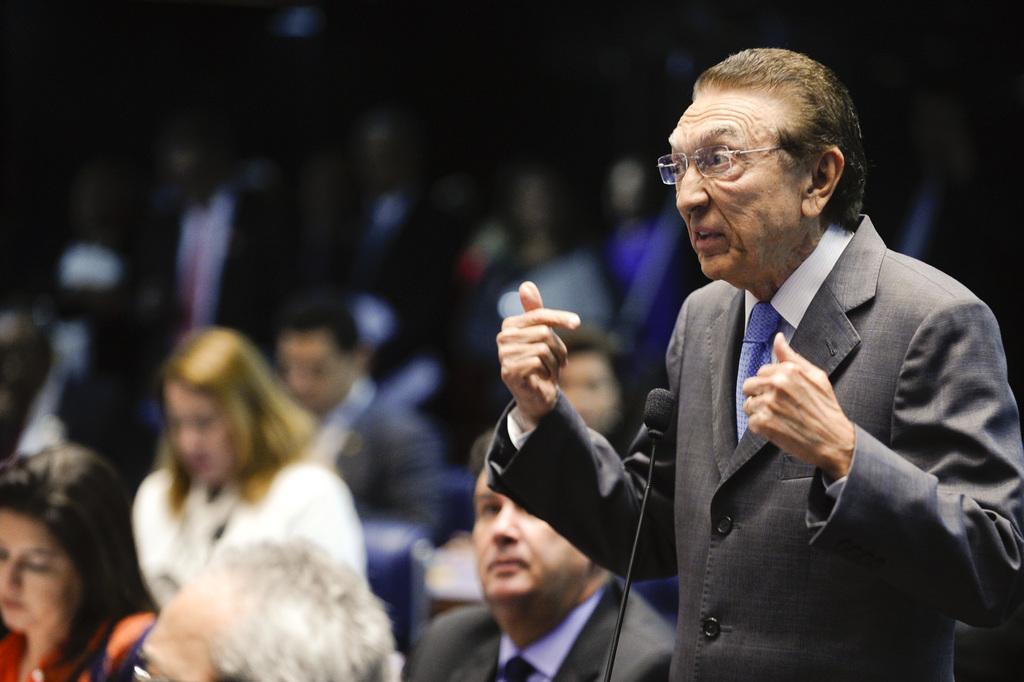In one or two sentences, can you explain what this image depicts? In the picture I can see a person wearing blazer, white shirt, tie and spectacles is standing on the right side of the image. Here I can see a mic in front of him. The background of the image is slightly blurred, where we can see a few people are sitting and the top of the image is dark. 